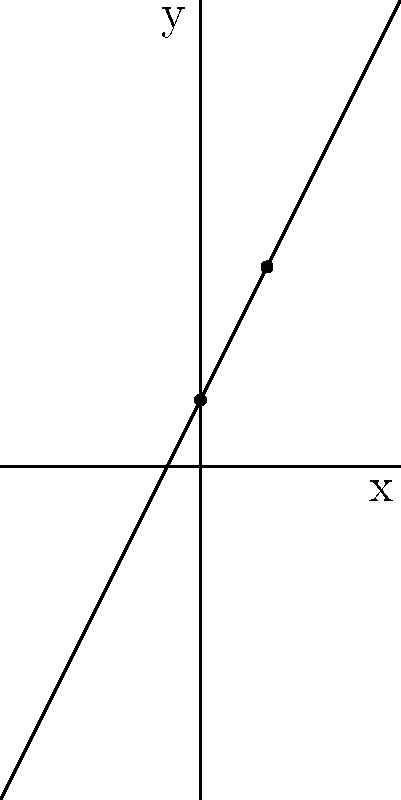Graph the line represented by the equation $y = 2x + 1$ on the coordinate plane. What are the coordinates of the y-intercept? To graph the line $y = 2x + 1$ and find the y-intercept, follow these steps:

1. Identify the slope and y-intercept form: $y = mx + b$
   In this case, $m = 2$ (slope) and $b = 1$ (y-intercept)

2. Plot the y-intercept:
   The y-intercept is where the line crosses the y-axis (when $x = 0$)
   Substitute $x = 0$ into the equation: $y = 2(0) + 1 = 1$
   So, the y-intercept is at the point $(0, 1)$

3. Use the slope to find another point:
   The slope is 2, which means "rise 2, run 1"
   From $(0, 1)$, go right 1 and up 2 to get to $(1, 3)$

4. Draw the line through these two points

5. The y-intercept is the point where the line crosses the y-axis, which we found in step 2: $(0, 1)$

Therefore, the coordinates of the y-intercept are $(0, 1)$.
Answer: $(0, 1)$ 